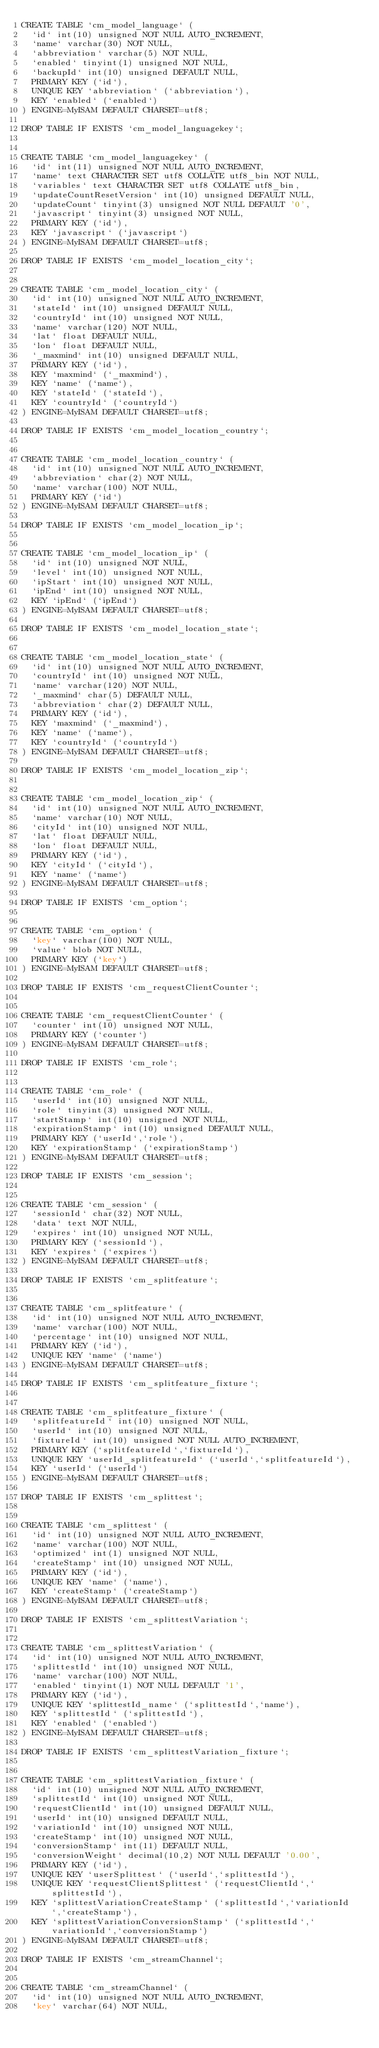Convert code to text. <code><loc_0><loc_0><loc_500><loc_500><_SQL_>CREATE TABLE `cm_model_language` (
  `id` int(10) unsigned NOT NULL AUTO_INCREMENT,
  `name` varchar(30) NOT NULL,
  `abbreviation` varchar(5) NOT NULL,
  `enabled` tinyint(1) unsigned NOT NULL,
  `backupId` int(10) unsigned DEFAULT NULL,
  PRIMARY KEY (`id`),
  UNIQUE KEY `abbreviation` (`abbreviation`),
  KEY `enabled` (`enabled`)
) ENGINE=MyISAM DEFAULT CHARSET=utf8;

DROP TABLE IF EXISTS `cm_model_languagekey`;


CREATE TABLE `cm_model_languagekey` (
  `id` int(11) unsigned NOT NULL AUTO_INCREMENT,
  `name` text CHARACTER SET utf8 COLLATE utf8_bin NOT NULL,
  `variables` text CHARACTER SET utf8 COLLATE utf8_bin,
  `updateCountResetVersion` int(10) unsigned DEFAULT NULL,
  `updateCount` tinyint(3) unsigned NOT NULL DEFAULT '0',
  `javascript` tinyint(3) unsigned NOT NULL,
  PRIMARY KEY (`id`),
  KEY `javascript` (`javascript`)
) ENGINE=MyISAM DEFAULT CHARSET=utf8;

DROP TABLE IF EXISTS `cm_model_location_city`;


CREATE TABLE `cm_model_location_city` (
  `id` int(10) unsigned NOT NULL AUTO_INCREMENT,
  `stateId` int(10) unsigned DEFAULT NULL,
  `countryId` int(10) unsigned NOT NULL,
  `name` varchar(120) NOT NULL,
  `lat` float DEFAULT NULL,
  `lon` float DEFAULT NULL,
  `_maxmind` int(10) unsigned DEFAULT NULL,
  PRIMARY KEY (`id`),
  KEY `maxmind` (`_maxmind`),
  KEY `name` (`name`),
  KEY `stateId` (`stateId`),
  KEY `countryId` (`countryId`)
) ENGINE=MyISAM DEFAULT CHARSET=utf8;

DROP TABLE IF EXISTS `cm_model_location_country`;


CREATE TABLE `cm_model_location_country` (
  `id` int(10) unsigned NOT NULL AUTO_INCREMENT,
  `abbreviation` char(2) NOT NULL,
  `name` varchar(100) NOT NULL,
  PRIMARY KEY (`id`)
) ENGINE=MyISAM DEFAULT CHARSET=utf8;

DROP TABLE IF EXISTS `cm_model_location_ip`;


CREATE TABLE `cm_model_location_ip` (
  `id` int(10) unsigned NOT NULL,
  `level` int(10) unsigned NOT NULL,
  `ipStart` int(10) unsigned NOT NULL,
  `ipEnd` int(10) unsigned NOT NULL,
  KEY `ipEnd` (`ipEnd`)
) ENGINE=MyISAM DEFAULT CHARSET=utf8;

DROP TABLE IF EXISTS `cm_model_location_state`;


CREATE TABLE `cm_model_location_state` (
  `id` int(10) unsigned NOT NULL AUTO_INCREMENT,
  `countryId` int(10) unsigned NOT NULL,
  `name` varchar(120) NOT NULL,
  `_maxmind` char(5) DEFAULT NULL,
  `abbreviation` char(2) DEFAULT NULL,
  PRIMARY KEY (`id`),
  KEY `maxmind` (`_maxmind`),
  KEY `name` (`name`),
  KEY `countryId` (`countryId`)
) ENGINE=MyISAM DEFAULT CHARSET=utf8;

DROP TABLE IF EXISTS `cm_model_location_zip`;


CREATE TABLE `cm_model_location_zip` (
  `id` int(10) unsigned NOT NULL AUTO_INCREMENT,
  `name` varchar(10) NOT NULL,
  `cityId` int(10) unsigned NOT NULL,
  `lat` float DEFAULT NULL,
  `lon` float DEFAULT NULL,
  PRIMARY KEY (`id`),
  KEY `cityId` (`cityId`),
  KEY `name` (`name`)
) ENGINE=MyISAM DEFAULT CHARSET=utf8;

DROP TABLE IF EXISTS `cm_option`;


CREATE TABLE `cm_option` (
  `key` varchar(100) NOT NULL,
  `value` blob NOT NULL,
  PRIMARY KEY (`key`)
) ENGINE=MyISAM DEFAULT CHARSET=utf8;

DROP TABLE IF EXISTS `cm_requestClientCounter`;


CREATE TABLE `cm_requestClientCounter` (
  `counter` int(10) unsigned NOT NULL,
  PRIMARY KEY (`counter`)
) ENGINE=MyISAM DEFAULT CHARSET=utf8;

DROP TABLE IF EXISTS `cm_role`;


CREATE TABLE `cm_role` (
  `userId` int(10) unsigned NOT NULL,
  `role` tinyint(3) unsigned NOT NULL,
  `startStamp` int(10) unsigned NOT NULL,
  `expirationStamp` int(10) unsigned DEFAULT NULL,
  PRIMARY KEY (`userId`,`role`),
  KEY `expirationStamp` (`expirationStamp`)
) ENGINE=MyISAM DEFAULT CHARSET=utf8;

DROP TABLE IF EXISTS `cm_session`;


CREATE TABLE `cm_session` (
  `sessionId` char(32) NOT NULL,
  `data` text NOT NULL,
  `expires` int(10) unsigned NOT NULL,
  PRIMARY KEY (`sessionId`),
  KEY `expires` (`expires`)
) ENGINE=MyISAM DEFAULT CHARSET=utf8;

DROP TABLE IF EXISTS `cm_splitfeature`;


CREATE TABLE `cm_splitfeature` (
  `id` int(10) unsigned NOT NULL AUTO_INCREMENT,
  `name` varchar(100) NOT NULL,
  `percentage` int(10) unsigned NOT NULL,
  PRIMARY KEY (`id`),
  UNIQUE KEY `name` (`name`)
) ENGINE=MyISAM DEFAULT CHARSET=utf8;

DROP TABLE IF EXISTS `cm_splitfeature_fixture`;


CREATE TABLE `cm_splitfeature_fixture` (
  `splitfeatureId` int(10) unsigned NOT NULL,
  `userId` int(10) unsigned NOT NULL,
  `fixtureId` int(10) unsigned NOT NULL AUTO_INCREMENT,
  PRIMARY KEY (`splitfeatureId`,`fixtureId`),
  UNIQUE KEY `userId_splitfeatureId` (`userId`,`splitfeatureId`),
  KEY `userId` (`userId`)
) ENGINE=MyISAM DEFAULT CHARSET=utf8;

DROP TABLE IF EXISTS `cm_splittest`;


CREATE TABLE `cm_splittest` (
  `id` int(10) unsigned NOT NULL AUTO_INCREMENT,
  `name` varchar(100) NOT NULL,
  `optimized` int(1) unsigned NOT NULL,
  `createStamp` int(10) unsigned NOT NULL,
  PRIMARY KEY (`id`),
  UNIQUE KEY `name` (`name`),
  KEY `createStamp` (`createStamp`)
) ENGINE=MyISAM DEFAULT CHARSET=utf8;

DROP TABLE IF EXISTS `cm_splittestVariation`;


CREATE TABLE `cm_splittestVariation` (
  `id` int(10) unsigned NOT NULL AUTO_INCREMENT,
  `splittestId` int(10) unsigned NOT NULL,
  `name` varchar(100) NOT NULL,
  `enabled` tinyint(1) NOT NULL DEFAULT '1',
  PRIMARY KEY (`id`),
  UNIQUE KEY `splittestId_name` (`splittestId`,`name`),
  KEY `splittestId` (`splittestId`),
  KEY `enabled` (`enabled`)
) ENGINE=MyISAM DEFAULT CHARSET=utf8;

DROP TABLE IF EXISTS `cm_splittestVariation_fixture`;


CREATE TABLE `cm_splittestVariation_fixture` (
  `id` int(10) unsigned NOT NULL AUTO_INCREMENT,
  `splittestId` int(10) unsigned NOT NULL,
  `requestClientId` int(10) unsigned DEFAULT NULL,
  `userId` int(10) unsigned DEFAULT NULL,
  `variationId` int(10) unsigned NOT NULL,
  `createStamp` int(10) unsigned NOT NULL,
  `conversionStamp` int(11) DEFAULT NULL,
  `conversionWeight` decimal(10,2) NOT NULL DEFAULT '0.00',
  PRIMARY KEY (`id`),
  UNIQUE KEY `userSplittest` (`userId`,`splittestId`),
  UNIQUE KEY `requestClientSplittest` (`requestClientId`,`splittestId`),
  KEY `splittestVariationCreateStamp` (`splittestId`,`variationId`,`createStamp`),
  KEY `splittestVariationConversionStamp` (`splittestId`,`variationId`,`conversionStamp`)
) ENGINE=MyISAM DEFAULT CHARSET=utf8;

DROP TABLE IF EXISTS `cm_streamChannel`;


CREATE TABLE `cm_streamChannel` (
  `id` int(10) unsigned NOT NULL AUTO_INCREMENT,
  `key` varchar(64) NOT NULL,</code> 